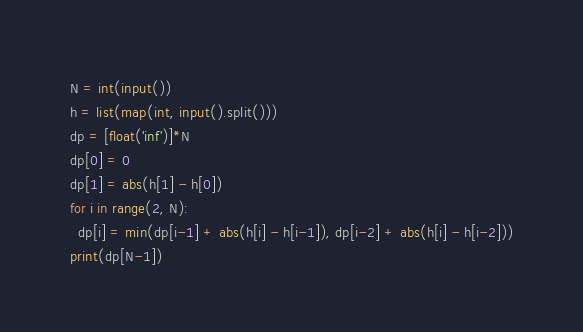Convert code to text. <code><loc_0><loc_0><loc_500><loc_500><_Python_>N = int(input())
h = list(map(int, input().split()))
dp = [float('inf')]*N
dp[0] = 0
dp[1] = abs(h[1] - h[0])
for i in range(2, N):
  dp[i] = min(dp[i-1] + abs(h[i] - h[i-1]), dp[i-2] + abs(h[i] - h[i-2]))
print(dp[N-1])</code> 